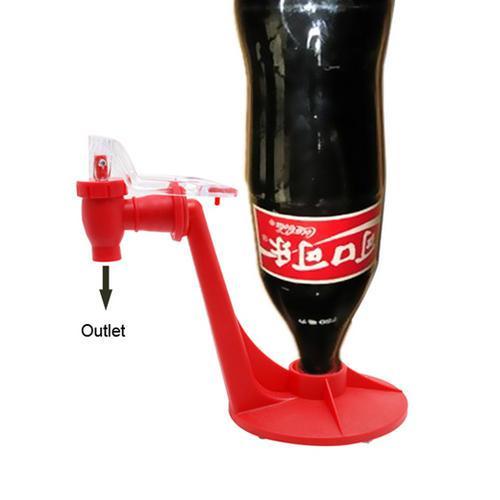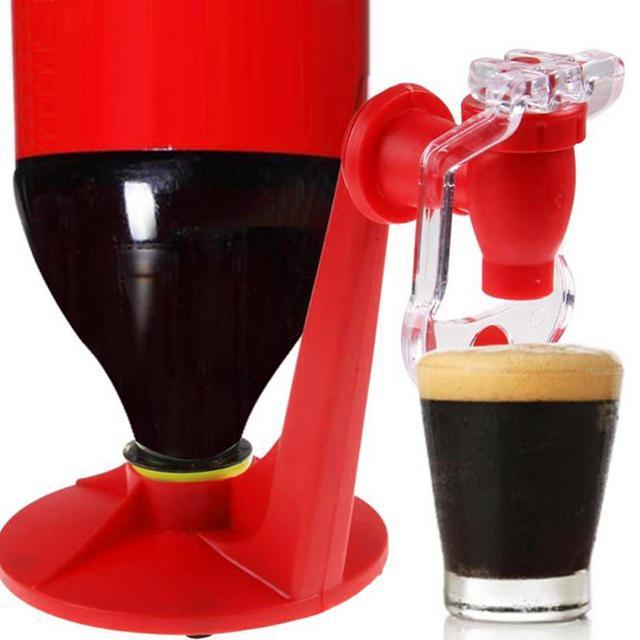The first image is the image on the left, the second image is the image on the right. Analyze the images presented: Is the assertion "In at least one image there is a upside coke bottle labeled in a different language sitting on a red tap." valid? Answer yes or no. Yes. The first image is the image on the left, the second image is the image on the right. For the images displayed, is the sentence "One of the soda bottles is green." factually correct? Answer yes or no. No. 